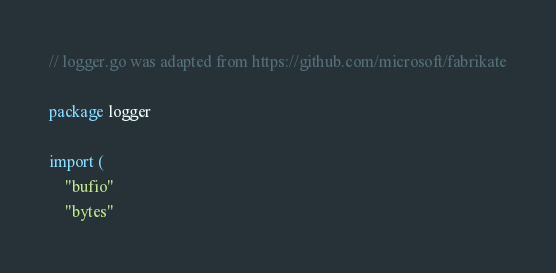Convert code to text. <code><loc_0><loc_0><loc_500><loc_500><_Go_>// logger.go was adapted from https://github.com/microsoft/fabrikate

package logger

import (
	"bufio"
	"bytes"</code> 